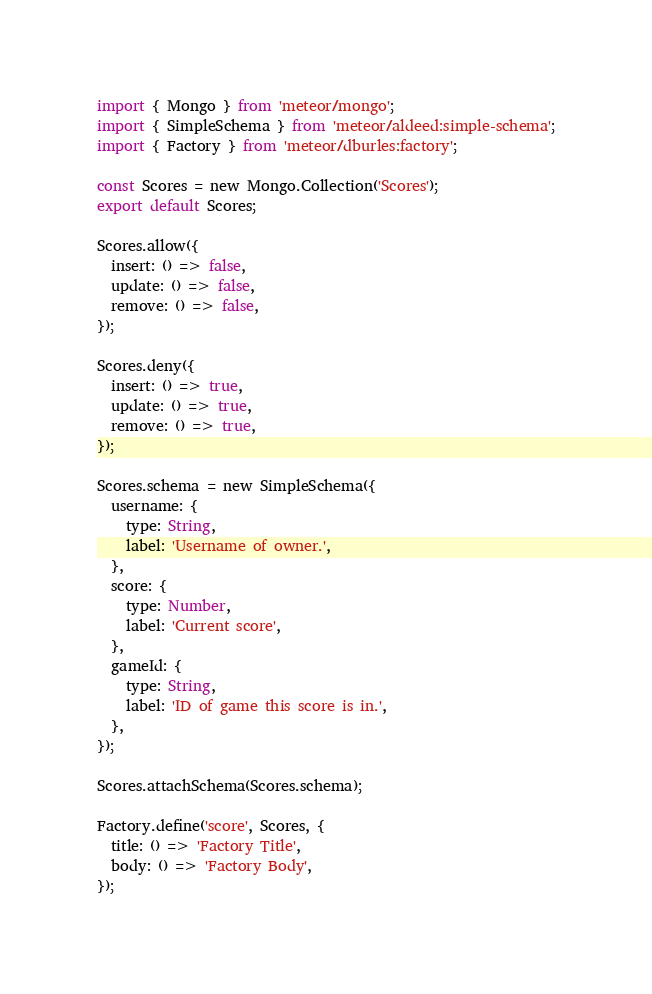<code> <loc_0><loc_0><loc_500><loc_500><_JavaScript_>import { Mongo } from 'meteor/mongo';
import { SimpleSchema } from 'meteor/aldeed:simple-schema';
import { Factory } from 'meteor/dburles:factory';

const Scores = new Mongo.Collection('Scores');
export default Scores;

Scores.allow({
  insert: () => false,
  update: () => false,
  remove: () => false,
});

Scores.deny({
  insert: () => true,
  update: () => true,
  remove: () => true,
});

Scores.schema = new SimpleSchema({
  username: {
    type: String,
    label: 'Username of owner.',
  },
  score: {
    type: Number,
    label: 'Current score',
  },
  gameId: {
    type: String,
    label: 'ID of game this score is in.',
  },
});

Scores.attachSchema(Scores.schema);

Factory.define('score', Scores, {
  title: () => 'Factory Title',
  body: () => 'Factory Body',
});
</code> 